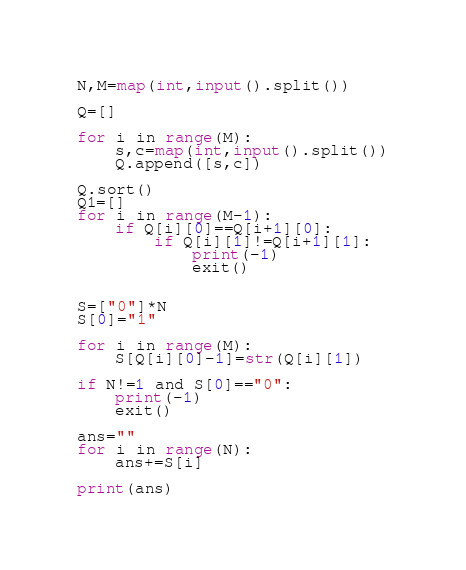<code> <loc_0><loc_0><loc_500><loc_500><_Python_>N,M=map(int,input().split())

Q=[]

for i in range(M):
    s,c=map(int,input().split())
    Q.append([s,c])

Q.sort()
Q1=[]
for i in range(M-1):
    if Q[i][0]==Q[i+1][0]:
        if Q[i][1]!=Q[i+1][1]:
            print(-1)
            exit()


S=["0"]*N
S[0]="1"

for i in range(M):
    S[Q[i][0]-1]=str(Q[i][1])

if N!=1 and S[0]=="0":
    print(-1)
    exit()

ans=""
for i in range(N):
    ans+=S[i]

print(ans)
</code> 